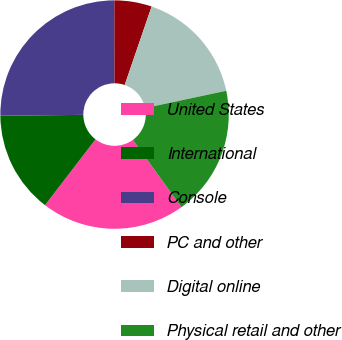Convert chart to OTSL. <chart><loc_0><loc_0><loc_500><loc_500><pie_chart><fcel>United States<fcel>International<fcel>Console<fcel>PC and other<fcel>Digital online<fcel>Physical retail and other<nl><fcel>20.37%<fcel>14.42%<fcel>25.13%<fcel>5.29%<fcel>16.4%<fcel>18.39%<nl></chart> 